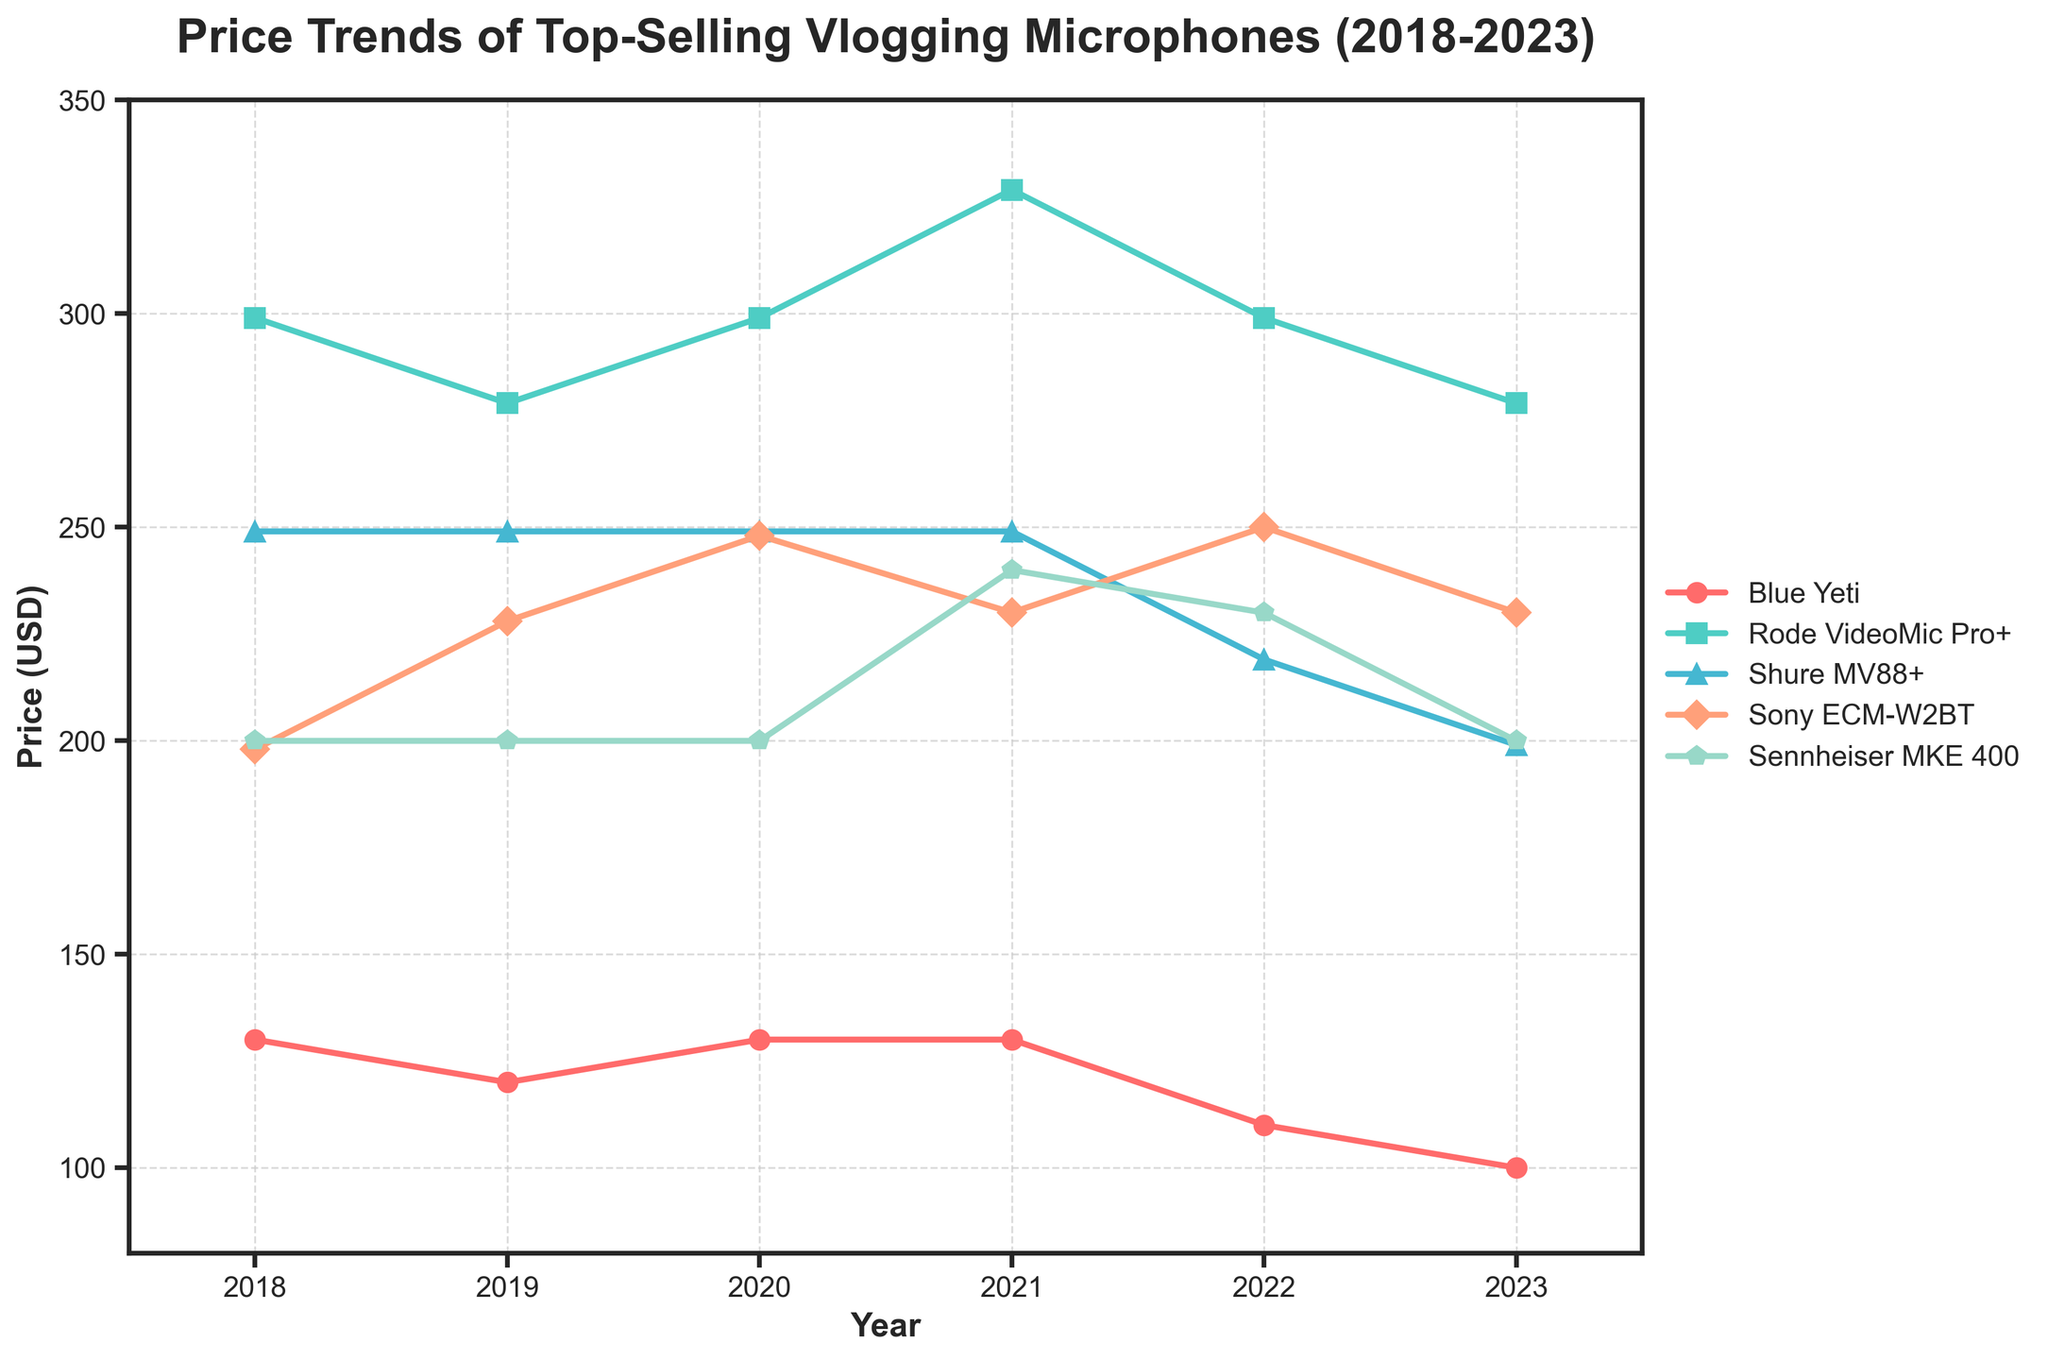Which microphone had the highest price in 2023? To find the highest price in 2023, we check the prices of all microphones for that year. Blue Yeti: $99.99, Rode VideoMic Pro+: $279.00, Shure MV88+: $199.00, Sony ECM-W2BT: $229.99, Sennheiser MKE 400: $199.95. The highest price is $279.00 for Rode VideoMic Pro+.
Answer: Rode VideoMic Pro+ By how much did the price of the Blue Yeti decrease from 2018 to 2023? To find the decrease, subtract the 2023 price from the 2018 price. Blue Yeti price in 2018: $129.99, in 2023: $99.99. The decrease is $129.99 - $99.99 = $30.
Answer: $30 What was the average price of the Sony ECM-W2BT microphone over the 6 years? To find the average, sum the prices for each year and divide by the number of years. Prices: $198.00, $228.00, $248.00, $229.99, $249.99, $229.99. Sum: $198.00 + $228.00 + $248.00 + $229.99 + $249.99 + $229.99 = $1383.97. The average is $1383.97 / 6 ≈ $230.66.
Answer: $230.66 Which microphone had the most stable price from 2018 to 2023? To determine stability, look for the smallest changes in prices over the years. The Sennheiser MKE 400 had prices: $199.95, $199.95, $199.95, $239.95, $229.95, $199.95, showing the least variation with only increases and decreases of $40. The other microphones showed more significant fluctuations.
Answer: Sennheiser MKE 400 How did the price of the Rode VideoMic Pro+ change from 2021 to 2022? To determine the change, subtract the 2022 price from the 2021 price. 2021 price: $329.00, 2022 price: $299.00. The change is $329.00 - $299.00 = $30 decrease.
Answer: Decrease by $30 Which microphone showed a price increase in 2022 compared to 2021? Compare the prices for each microphone between those years. Blue Yeti: $129.99 to $109.99 (decrease). Rode VideoMic Pro+: $329.00 to $299.00 (decrease). Shure MV88+: $249.00 to $219.00 (decrease). Sony ECM-W2BT: $229.99 to $249.99 (increase). Sennheiser MKE 400: $239.95 to $229.95 (decrease). Only Sony ECM-W2BT showed an increase.
Answer: Sony ECM-W2BT What is the trend in the price of the Shure MV88+ from 2018 to 2023? Observing Shure MV88+ prices from 2018 to 2023: $249.00, $249.00, $249.00, $249.00, $219.00, $199.00, we see it remained stable at $249.00 from 2018 to 2021, then decreased in 2022 to $219.00 and further in 2023 to $199.00.
Answer: Stable then decreasing Which year did the Blue Yeti have the lowest price, and what was the price? Check the Blue Yeti prices over the years: $129.99 (2018), $119.99 (2019), $129.99 (2020), $129.99 (2021), $109.99 (2022), $99.99 (2023). The lowest price occurred in 2023, at $99.99.
Answer: 2023, $99.99 How many microphones had a price reduction between 2022 and 2023? Compare the 2022 and 2023 prices for each microphone:
   - Blue Yeti: $109.99 to $99.99 (reduction)
   - Rode VideoMic Pro+: $299.00 to $279.00 (reduction)
   - Shure MV88+: $219.00 to $199.00 (reduction)
   - Sony ECM-W2BT: $249.99 to $229.99 (reduction)
   - Sennheiser MKE 400: $229.95 to $199.95 (reduction). All five microphones had a reduction.
Answer: 5 